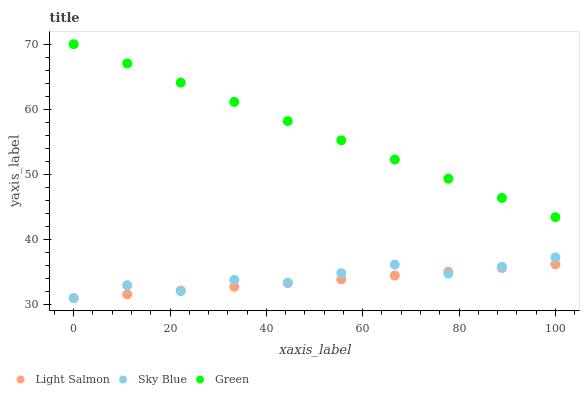Does Light Salmon have the minimum area under the curve?
Answer yes or no. Yes. Does Green have the maximum area under the curve?
Answer yes or no. Yes. Does Green have the minimum area under the curve?
Answer yes or no. No. Does Light Salmon have the maximum area under the curve?
Answer yes or no. No. Is Light Salmon the smoothest?
Answer yes or no. Yes. Is Sky Blue the roughest?
Answer yes or no. Yes. Is Green the smoothest?
Answer yes or no. No. Is Green the roughest?
Answer yes or no. No. Does Sky Blue have the lowest value?
Answer yes or no. Yes. Does Green have the lowest value?
Answer yes or no. No. Does Green have the highest value?
Answer yes or no. Yes. Does Light Salmon have the highest value?
Answer yes or no. No. Is Light Salmon less than Green?
Answer yes or no. Yes. Is Green greater than Sky Blue?
Answer yes or no. Yes. Does Sky Blue intersect Light Salmon?
Answer yes or no. Yes. Is Sky Blue less than Light Salmon?
Answer yes or no. No. Is Sky Blue greater than Light Salmon?
Answer yes or no. No. Does Light Salmon intersect Green?
Answer yes or no. No. 